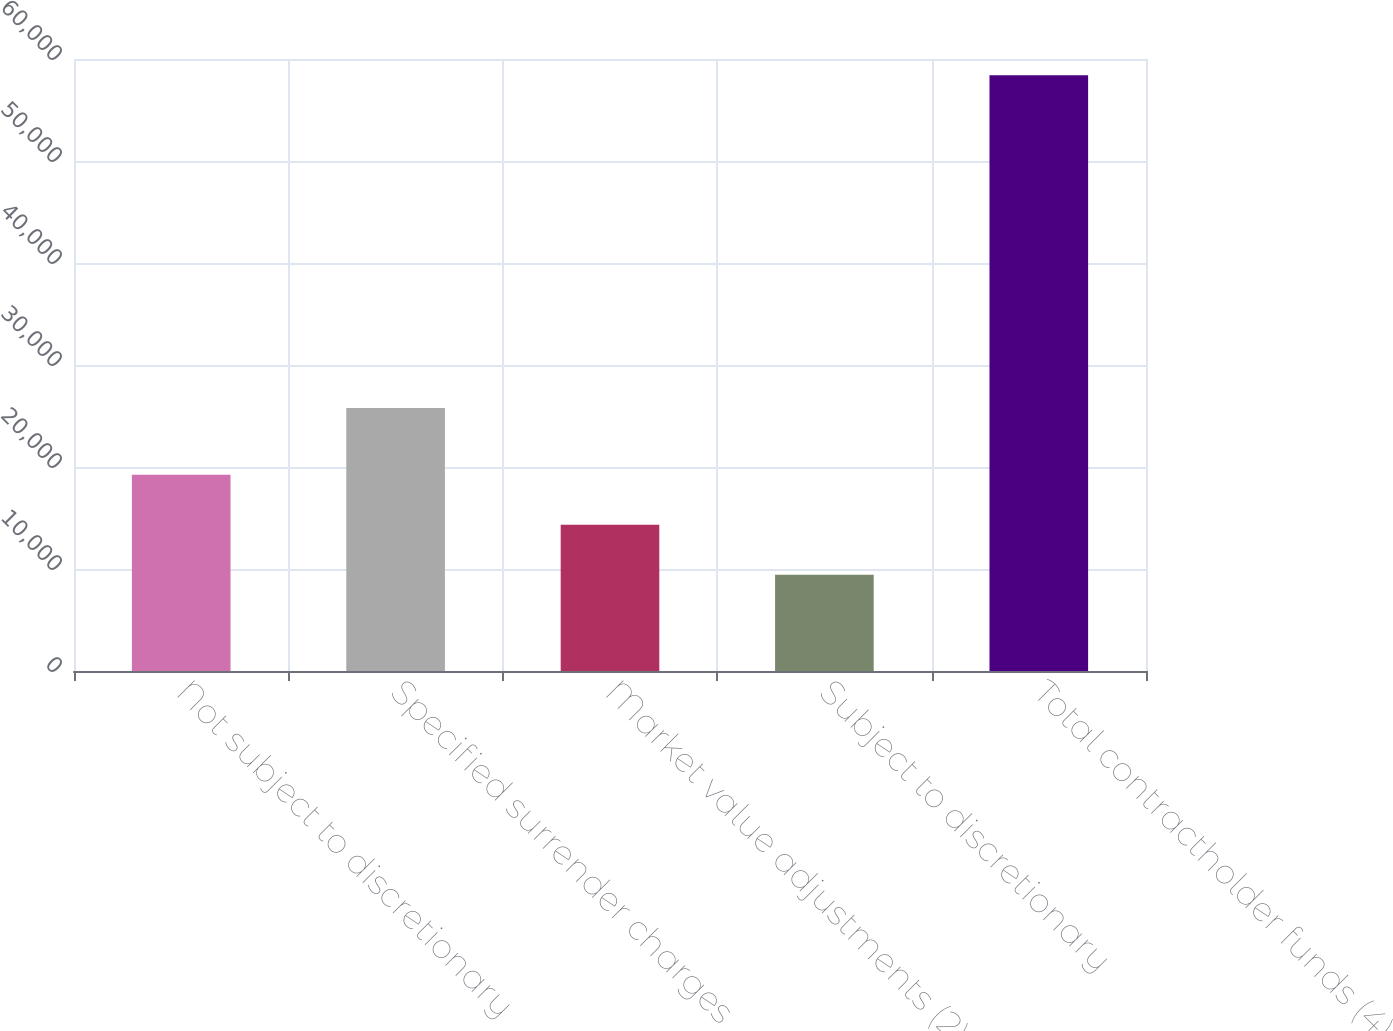Convert chart to OTSL. <chart><loc_0><loc_0><loc_500><loc_500><bar_chart><fcel>Not subject to discretionary<fcel>Specified surrender charges<fcel>Market value adjustments (2)<fcel>Subject to discretionary<fcel>Total contractholder funds (4)<nl><fcel>19236.2<fcel>25781<fcel>14339.1<fcel>9442<fcel>58413<nl></chart> 